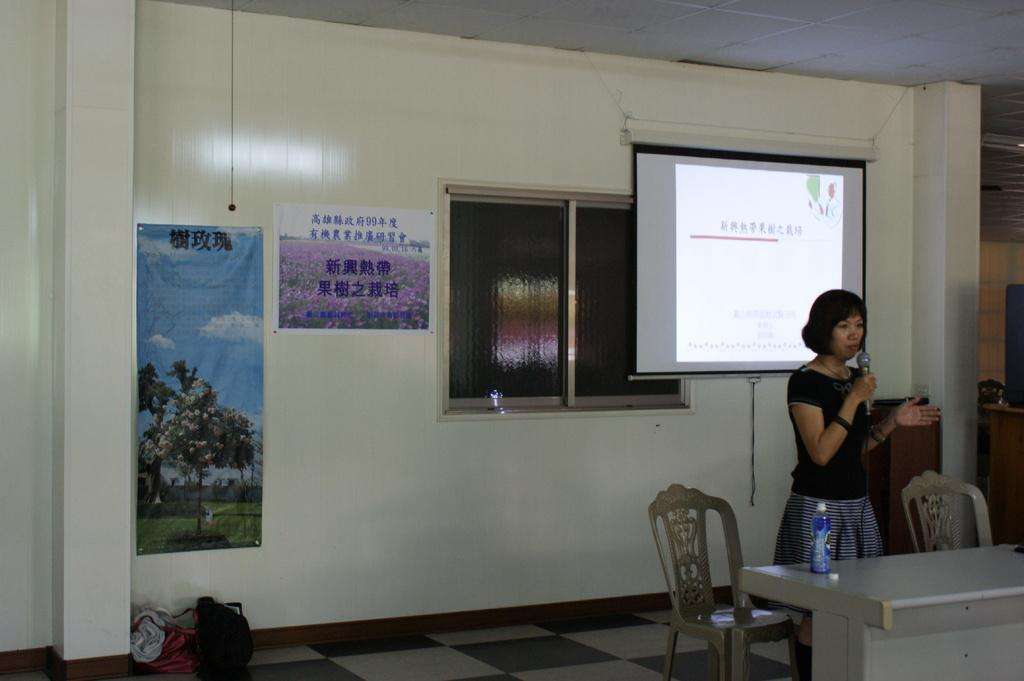Who is the main subject in the image? There is a woman in the image. What is the woman holding in her hand? The woman is holding a mic in her hand. What is the woman's posture in the image? The woman is standing in the image. What type of furniture can be seen in the image? There are chairs in the image. What is placed on the table in the image? There is a bottle on a table in the image. What electronic device is present in the image? There is a screen in the image. What architectural feature is visible in the image? There is a window in the image. What type of decorations are on the wall in the image? There are posters on the wall in the image. What type of decision can be seen being made in the image? There is no decision-making process depicted in the image. What example of a drug can be seen in the image? There is no drug present in the image. 